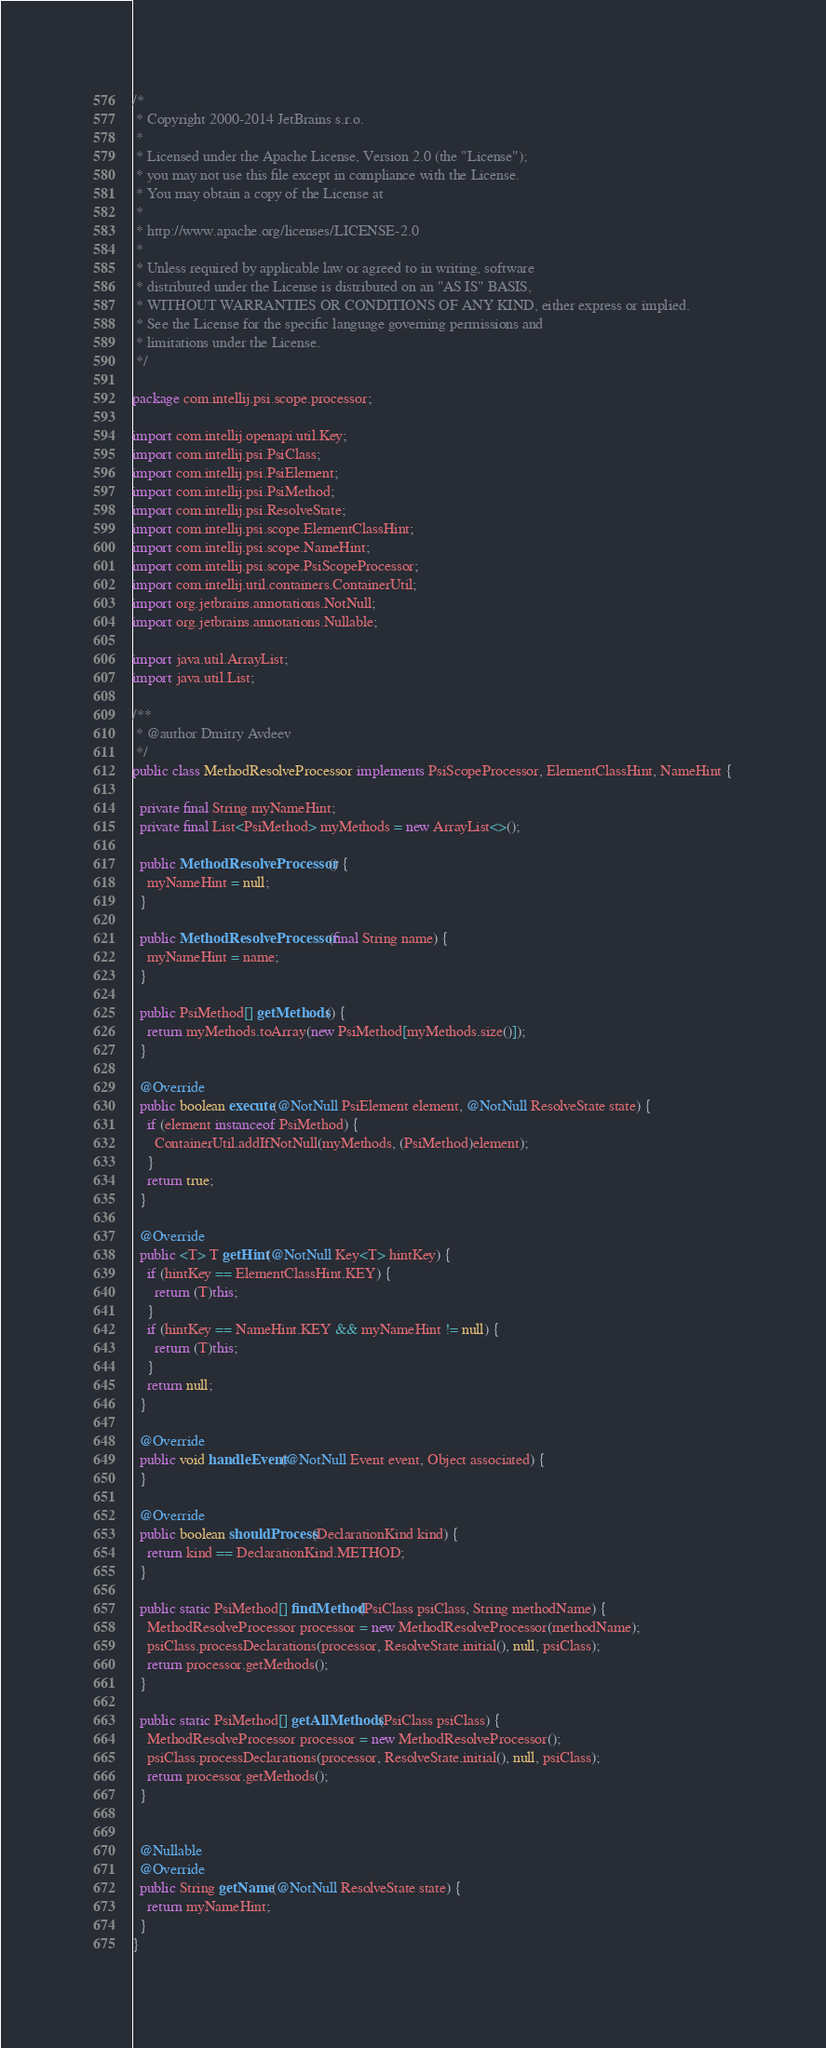<code> <loc_0><loc_0><loc_500><loc_500><_Java_>/*
 * Copyright 2000-2014 JetBrains s.r.o.
 *
 * Licensed under the Apache License, Version 2.0 (the "License");
 * you may not use this file except in compliance with the License.
 * You may obtain a copy of the License at
 *
 * http://www.apache.org/licenses/LICENSE-2.0
 *
 * Unless required by applicable law or agreed to in writing, software
 * distributed under the License is distributed on an "AS IS" BASIS,
 * WITHOUT WARRANTIES OR CONDITIONS OF ANY KIND, either express or implied.
 * See the License for the specific language governing permissions and
 * limitations under the License.
 */

package com.intellij.psi.scope.processor;

import com.intellij.openapi.util.Key;
import com.intellij.psi.PsiClass;
import com.intellij.psi.PsiElement;
import com.intellij.psi.PsiMethod;
import com.intellij.psi.ResolveState;
import com.intellij.psi.scope.ElementClassHint;
import com.intellij.psi.scope.NameHint;
import com.intellij.psi.scope.PsiScopeProcessor;
import com.intellij.util.containers.ContainerUtil;
import org.jetbrains.annotations.NotNull;
import org.jetbrains.annotations.Nullable;

import java.util.ArrayList;
import java.util.List;

/**
 * @author Dmitry Avdeev
 */
public class MethodResolveProcessor implements PsiScopeProcessor, ElementClassHint, NameHint {

  private final String myNameHint;
  private final List<PsiMethod> myMethods = new ArrayList<>();

  public MethodResolveProcessor() {
    myNameHint = null;
  }

  public MethodResolveProcessor(final String name) {
    myNameHint = name;
  }

  public PsiMethod[] getMethods() {
    return myMethods.toArray(new PsiMethod[myMethods.size()]);
  }

  @Override
  public boolean execute(@NotNull PsiElement element, @NotNull ResolveState state) {
    if (element instanceof PsiMethod) {
      ContainerUtil.addIfNotNull(myMethods, (PsiMethod)element);
    }
    return true;
  }

  @Override
  public <T> T getHint(@NotNull Key<T> hintKey) {
    if (hintKey == ElementClassHint.KEY) {
      return (T)this;
    }
    if (hintKey == NameHint.KEY && myNameHint != null) {
      return (T)this;
    }
    return null;
  }

  @Override
  public void handleEvent(@NotNull Event event, Object associated) {
  }

  @Override
  public boolean shouldProcess(DeclarationKind kind) {
    return kind == DeclarationKind.METHOD;
  }

  public static PsiMethod[] findMethod(PsiClass psiClass, String methodName) {
    MethodResolveProcessor processor = new MethodResolveProcessor(methodName);
    psiClass.processDeclarations(processor, ResolveState.initial(), null, psiClass);
    return processor.getMethods();
  }

  public static PsiMethod[] getAllMethods(PsiClass psiClass) {
    MethodResolveProcessor processor = new MethodResolveProcessor();
    psiClass.processDeclarations(processor, ResolveState.initial(), null, psiClass);
    return processor.getMethods();
  }


  @Nullable
  @Override
  public String getName(@NotNull ResolveState state) {
    return myNameHint;
  }
}
</code> 